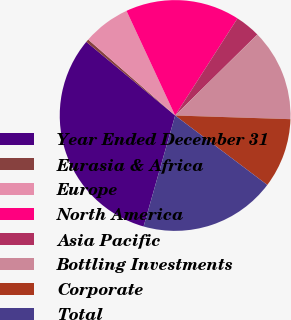<chart> <loc_0><loc_0><loc_500><loc_500><pie_chart><fcel>Year Ended December 31<fcel>Eurasia & Africa<fcel>Europe<fcel>North America<fcel>Asia Pacific<fcel>Bottling Investments<fcel>Corporate<fcel>Total<nl><fcel>31.61%<fcel>0.41%<fcel>6.65%<fcel>16.01%<fcel>3.53%<fcel>12.89%<fcel>9.77%<fcel>19.13%<nl></chart> 